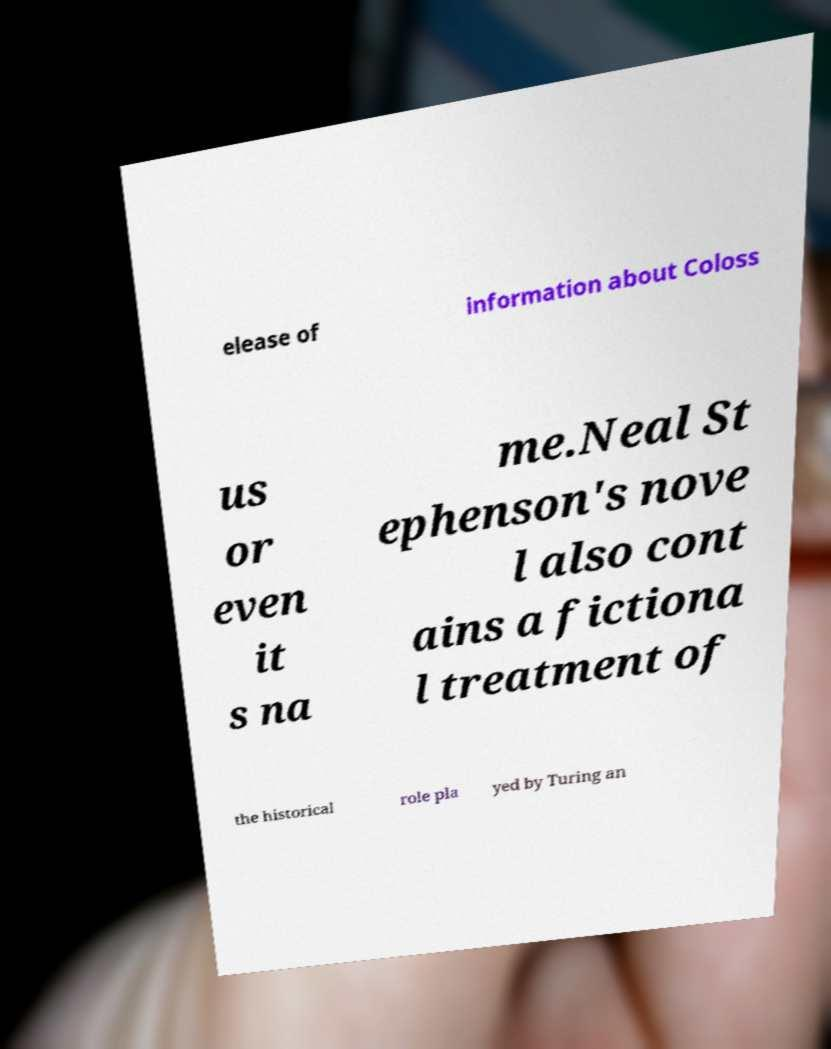Could you assist in decoding the text presented in this image and type it out clearly? elease of information about Coloss us or even it s na me.Neal St ephenson's nove l also cont ains a fictiona l treatment of the historical role pla yed by Turing an 